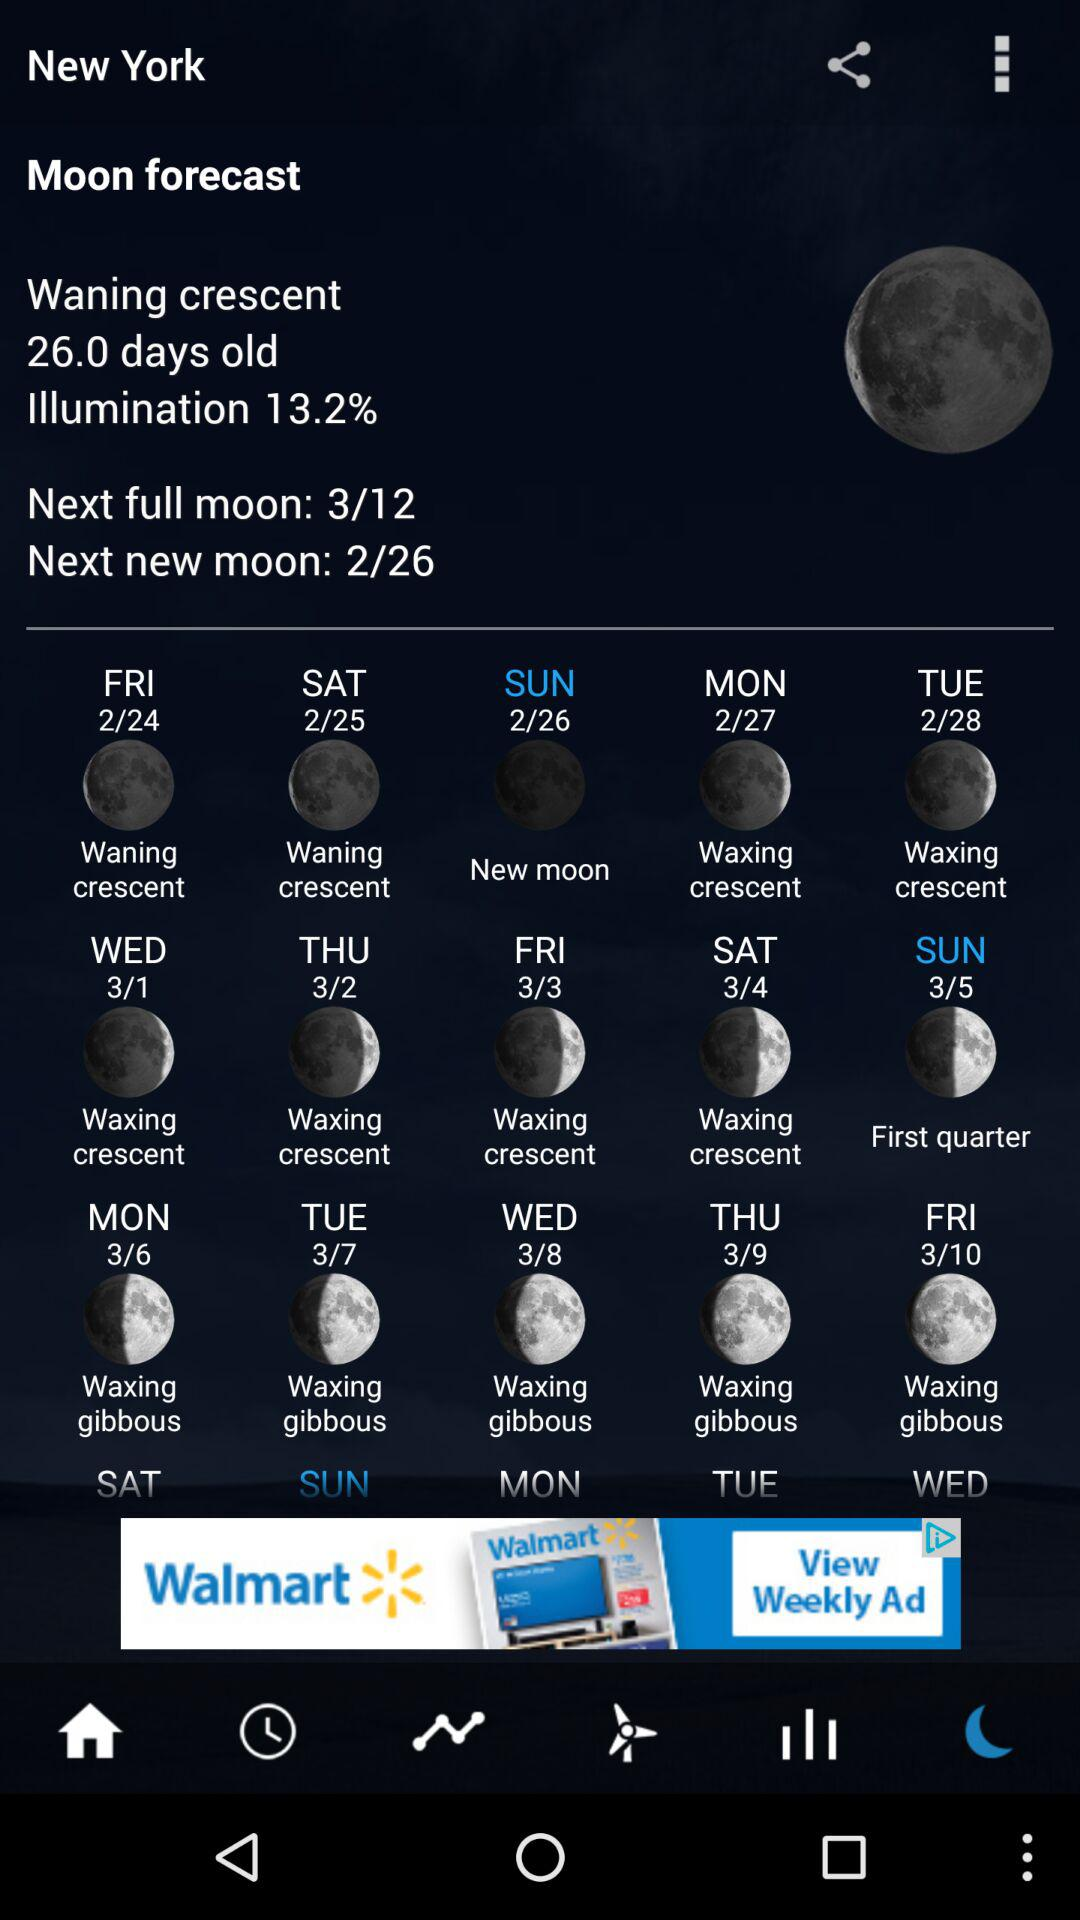When will be the next full moon? The next full moon will be on March 12. 